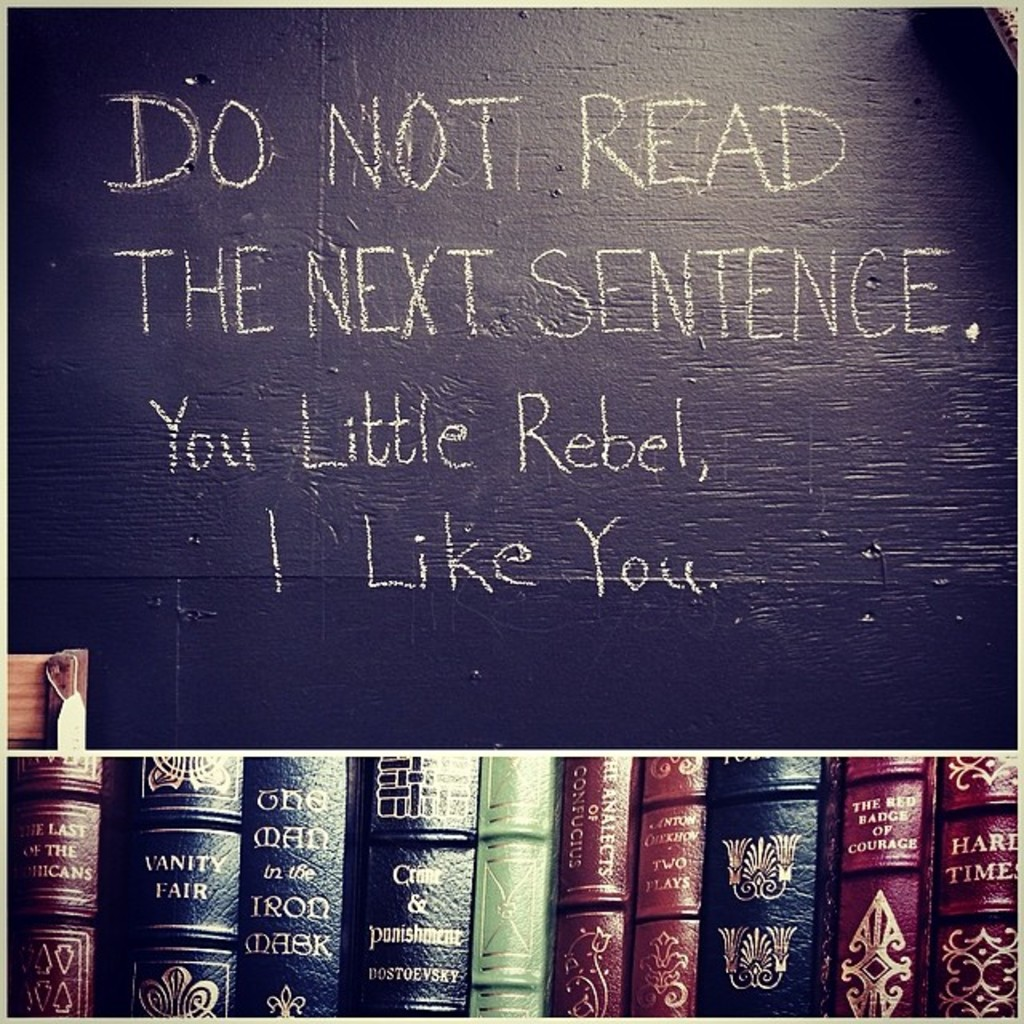What do you think the person who wrote the message on the blackboard was trying to achieve? The message on the blackboard, employing reverse psychology with a humorous twist, was likely intended to engage and amuse the reader. By calling the reader a 'little rebel,' it creates a bonding joke, suggesting that breaking small rules can be a playful, positive trait. This clever writing fosters a light-hearted connection and makes the environment more welcoming and engaging. 